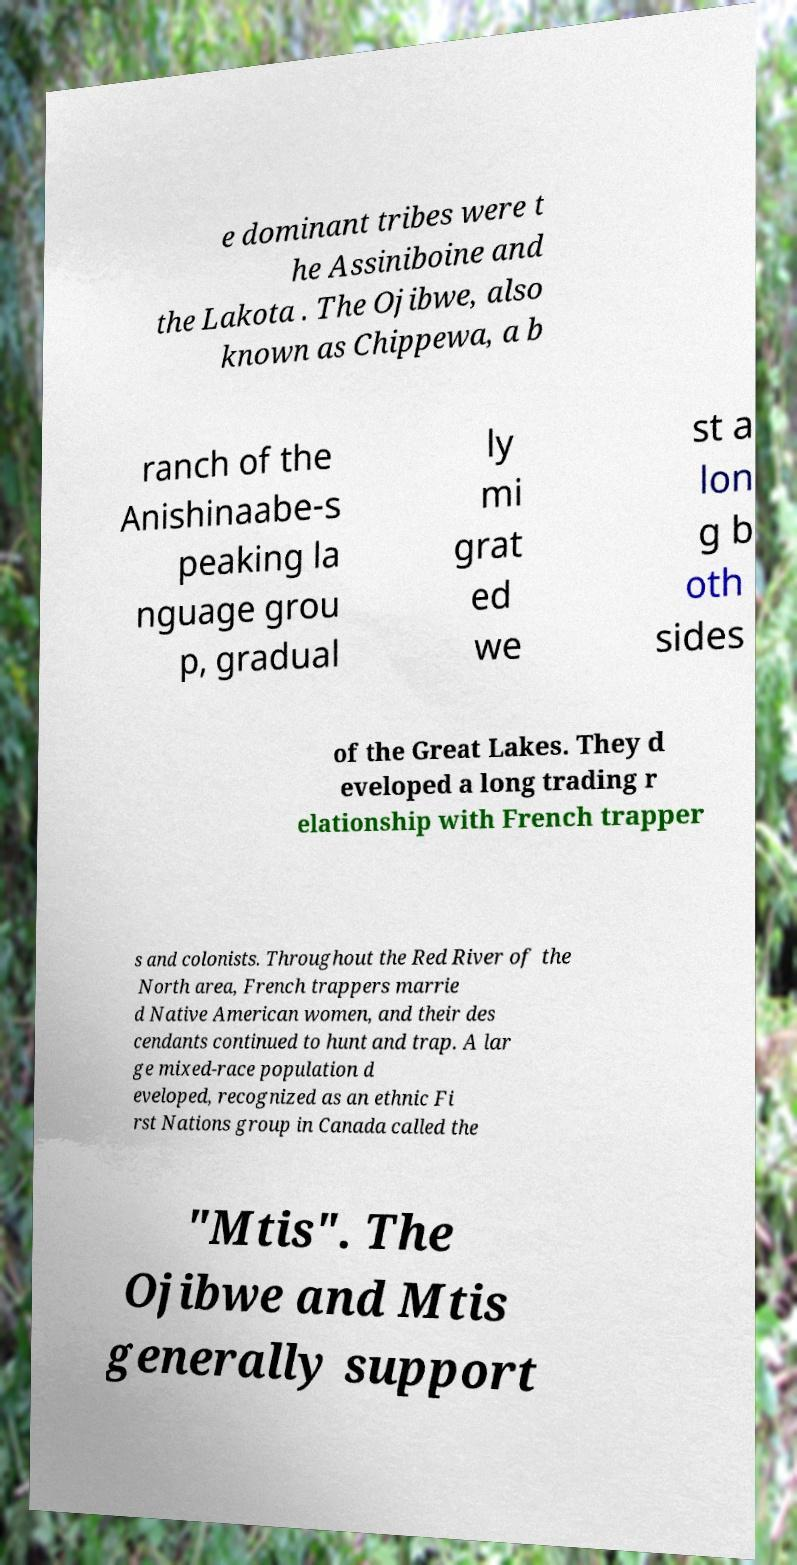Could you extract and type out the text from this image? e dominant tribes were t he Assiniboine and the Lakota . The Ojibwe, also known as Chippewa, a b ranch of the Anishinaabe-s peaking la nguage grou p, gradual ly mi grat ed we st a lon g b oth sides of the Great Lakes. They d eveloped a long trading r elationship with French trapper s and colonists. Throughout the Red River of the North area, French trappers marrie d Native American women, and their des cendants continued to hunt and trap. A lar ge mixed-race population d eveloped, recognized as an ethnic Fi rst Nations group in Canada called the "Mtis". The Ojibwe and Mtis generally support 